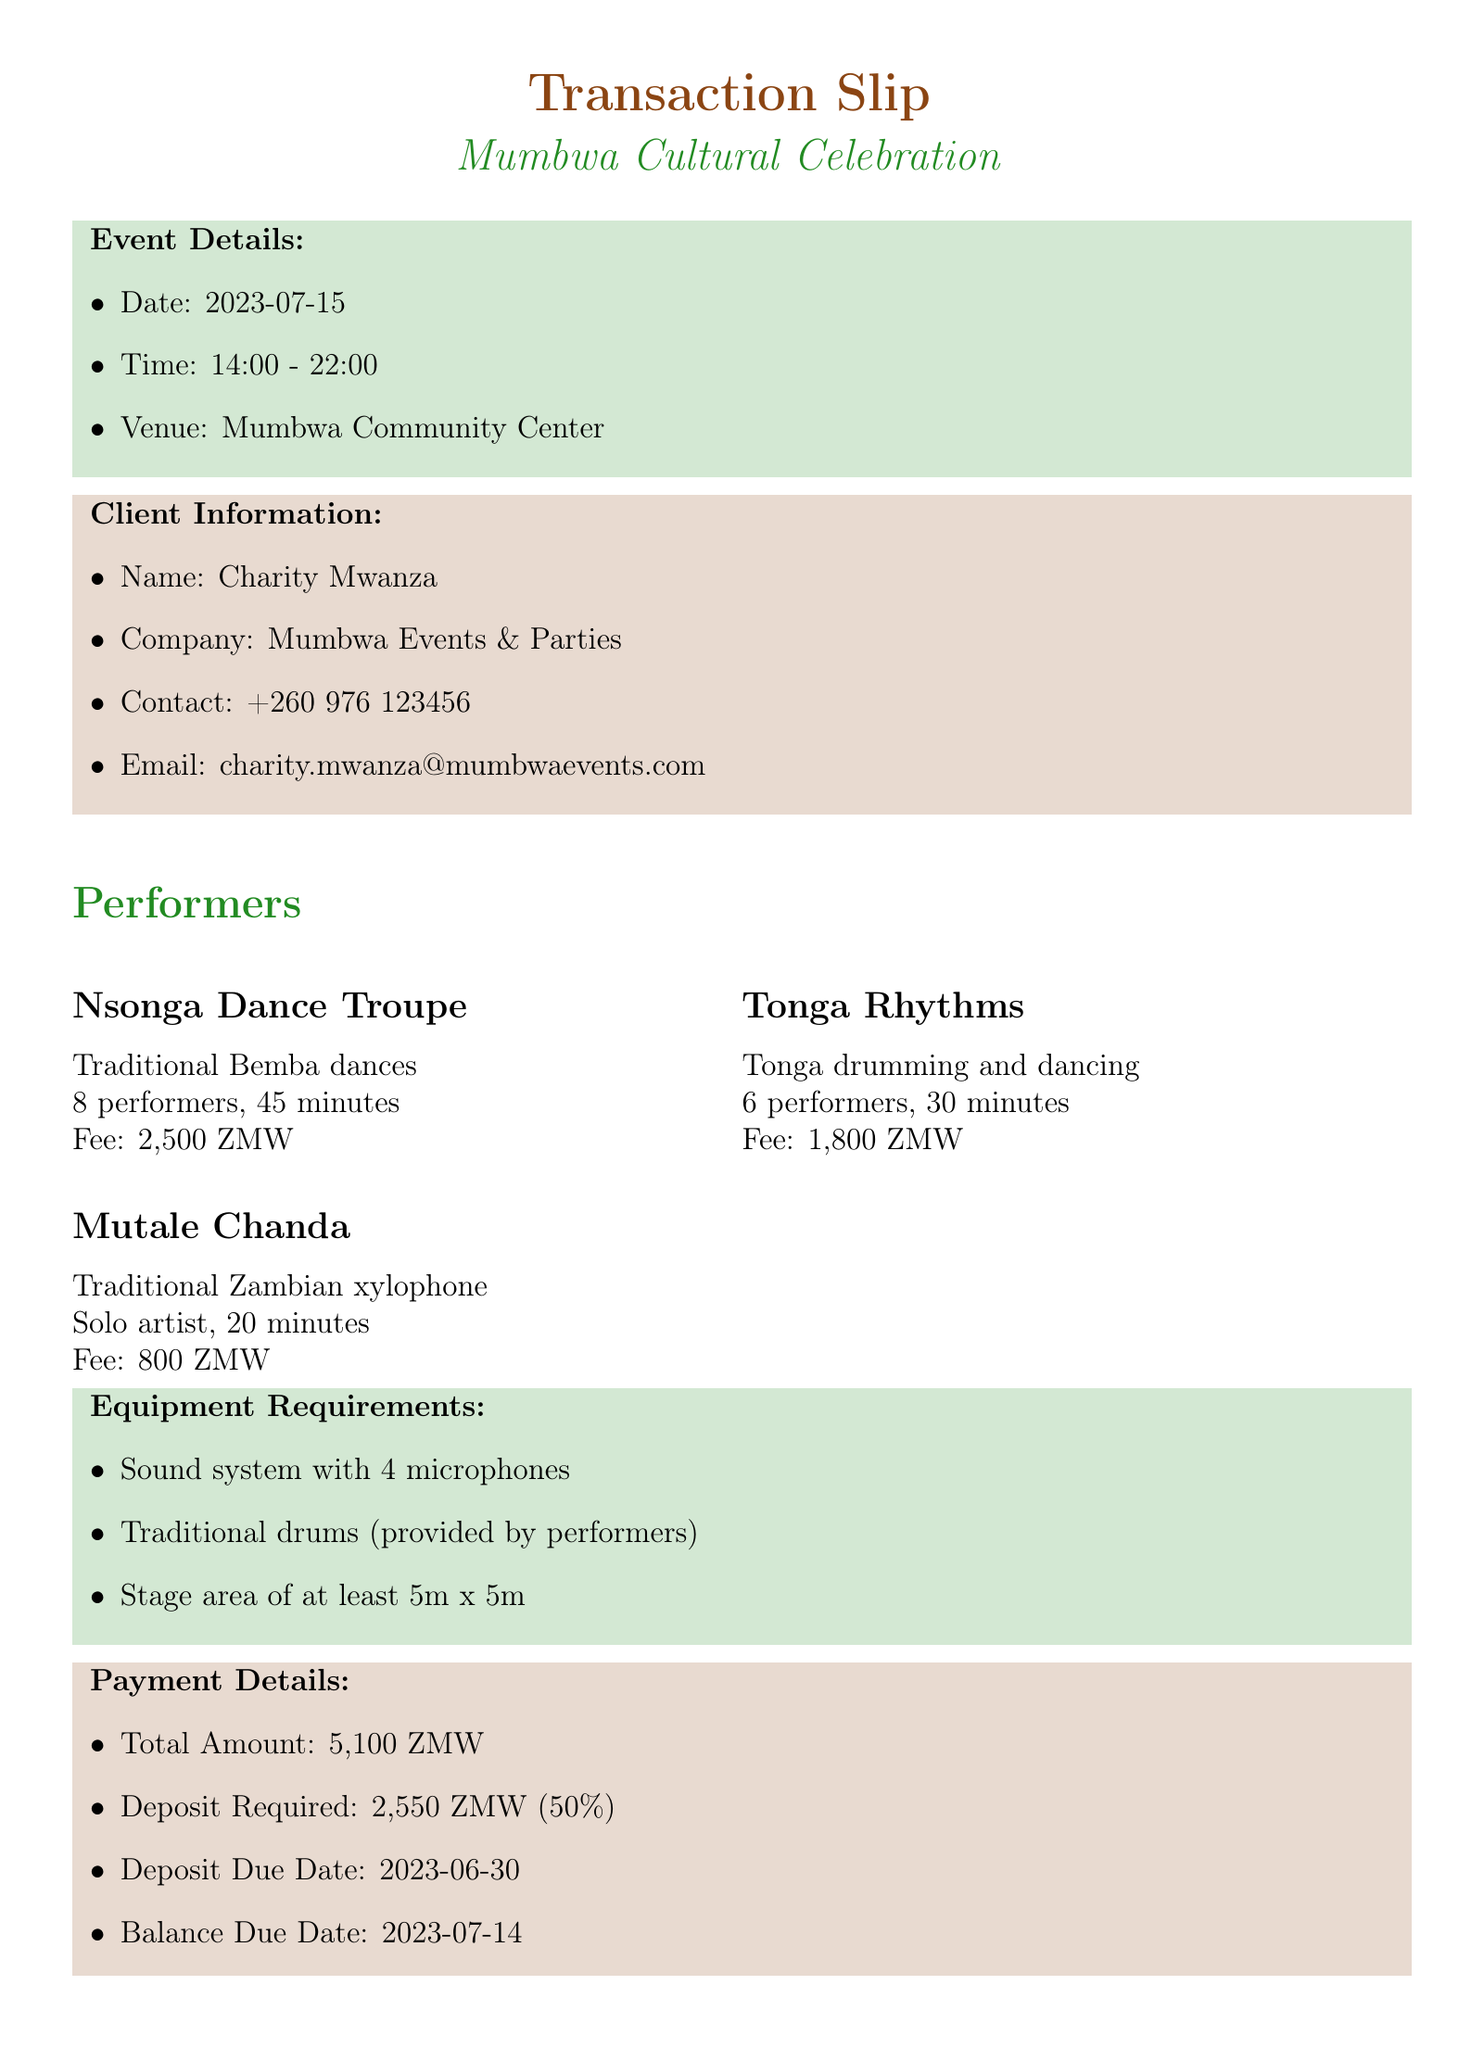what is the name of the event? The document specifies the name of the event as "Mumbwa Cultural Celebration."
Answer: Mumbwa Cultural Celebration what is the date of the event? The event date is listed in the document as "2023-07-15."
Answer: 2023-07-15 how many performers are in the Nsonga Dance Troupe? The document provides the number of performers for the Nsonga Dance Troupe as 8.
Answer: 8 what is the total amount for the performances? The total amount for the performances can be found in the payment details section as "5,100 ZMW."
Answer: 5,100 ZMW by what date is the deposit due? The deposit due date is mentioned in the payment details as "2023-06-30."
Answer: 2023-06-30 what is the duration of Mutale Chanda's performance? The performance duration for Mutale Chanda is indicated in the document as "20 minutes."
Answer: 20 minutes what is one of the equipment requirements? The document lists multiple equipment requirements including "Sound system with 4 microphones."
Answer: Sound system with 4 microphones what happens if cancellation occurs within 7 days of the event? The terms and conditions specify that cancellation within 7 days results in forfeiture of the deposit.
Answer: Forfeiture of the deposit who is the client? The document identifies the client as "Charity Mwanza."
Answer: Charity Mwanza 